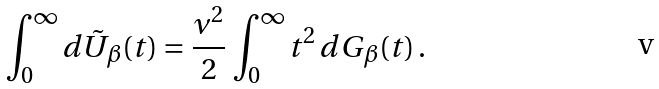<formula> <loc_0><loc_0><loc_500><loc_500>\int _ { 0 } ^ { \infty } d \tilde { U } _ { \beta } ( t ) = \frac { \nu ^ { 2 } } { 2 } \, \int _ { 0 } ^ { \infty } t ^ { 2 } \, d G _ { \beta } ( t ) \, .</formula> 